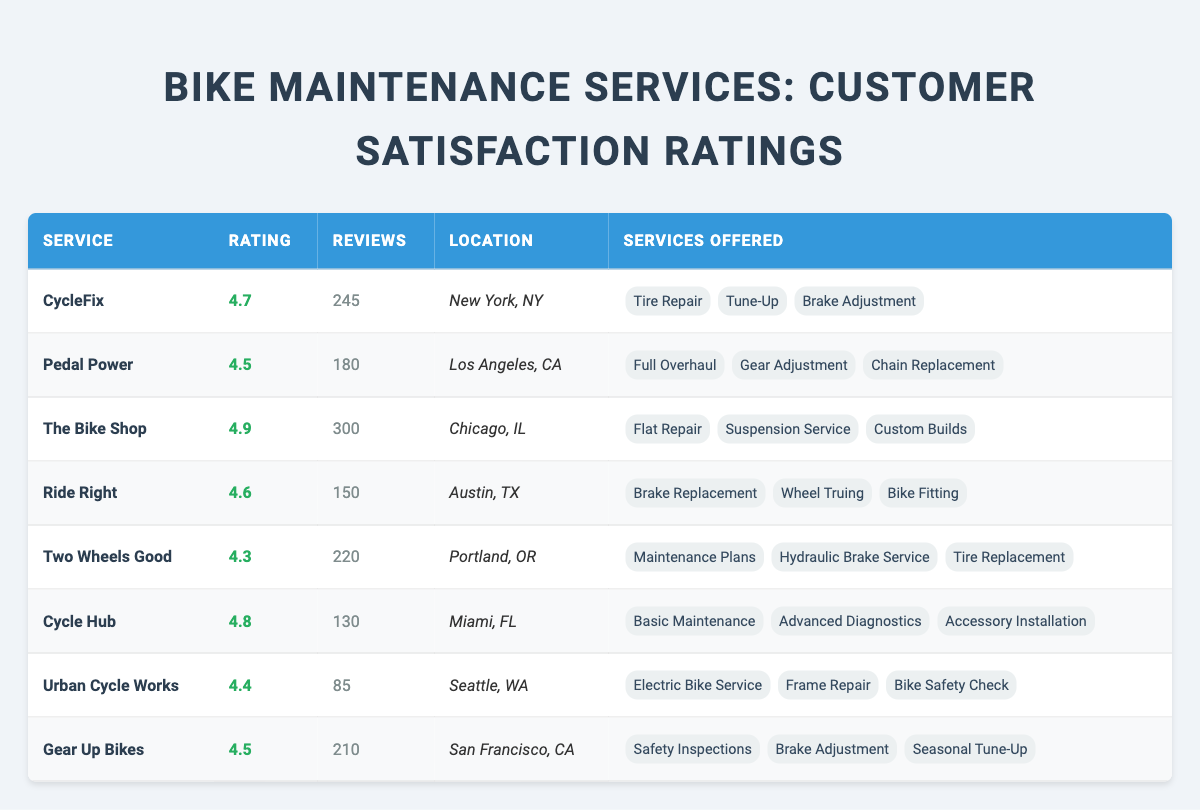What is the highest customer rating among the bike maintenance services? The highest rating is listed in the "Rating" column for "The Bike Shop," which shows a rating of 4.9.
Answer: 4.9 Which bike maintenance service has the fewest reviews? Looking at the "Reviews" column, "Urban Cycle Works" has the lowest number of reviews at 85.
Answer: 85 How many total reviews are there across all bike maintenance services? To find the total, add all the numbers in the "Reviews" column: 245 + 180 + 300 + 150 + 220 + 130 + 85 + 210 = 1,520.
Answer: 1,520 What is the average customer rating for the bike maintenance services? First, sum up the ratings: 4.7 + 4.5 + 4.9 + 4.6 + 4.3 + 4.8 + 4.4 + 4.5 = 36.7. Then divide by the number of services (8): 36.7 / 8 = 4.5875, approximately 4.59.
Answer: 4.59 Which service has the most customer reviews and what is the rating? "The Bike Shop" has 300 reviews, the highest among all, with a rating of 4.9.
Answer: 300 reviews, rating 4.9 Are there any bike maintenance services located in Austin, TX? Yes, "Ride Right" is located in Austin, TX.
Answer: Yes Which bike maintenance service offers the 'Brake Adjustment' as a service? Three services listed offer 'Brake Adjustment': "CycleFix," "Pedal Power," and "Gear Up Bikes."
Answer: Yes, three services What is the difference in customer ratings between the highest-rated and lowest-rated services? The highest rating is 4.9 (The Bike Shop) and the lowest is 4.3 (Two Wheels Good). The difference is 4.9 - 4.3 = 0.6.
Answer: 0.6 In which location is "Cycle Hub" located and how many reviews did it receive? "Cycle Hub" is located in Miami, FL, and it received 130 reviews.
Answer: Miami, FL; 130 reviews Which bike maintenance service offers the most comprehensive service list based on offered services? "The Bike Shop" offers the most comprehensive services with 3 listed: "Flat Repair," "Suspension Service," and "Custom Builds."
Answer: The Bike Shop, 3 services 